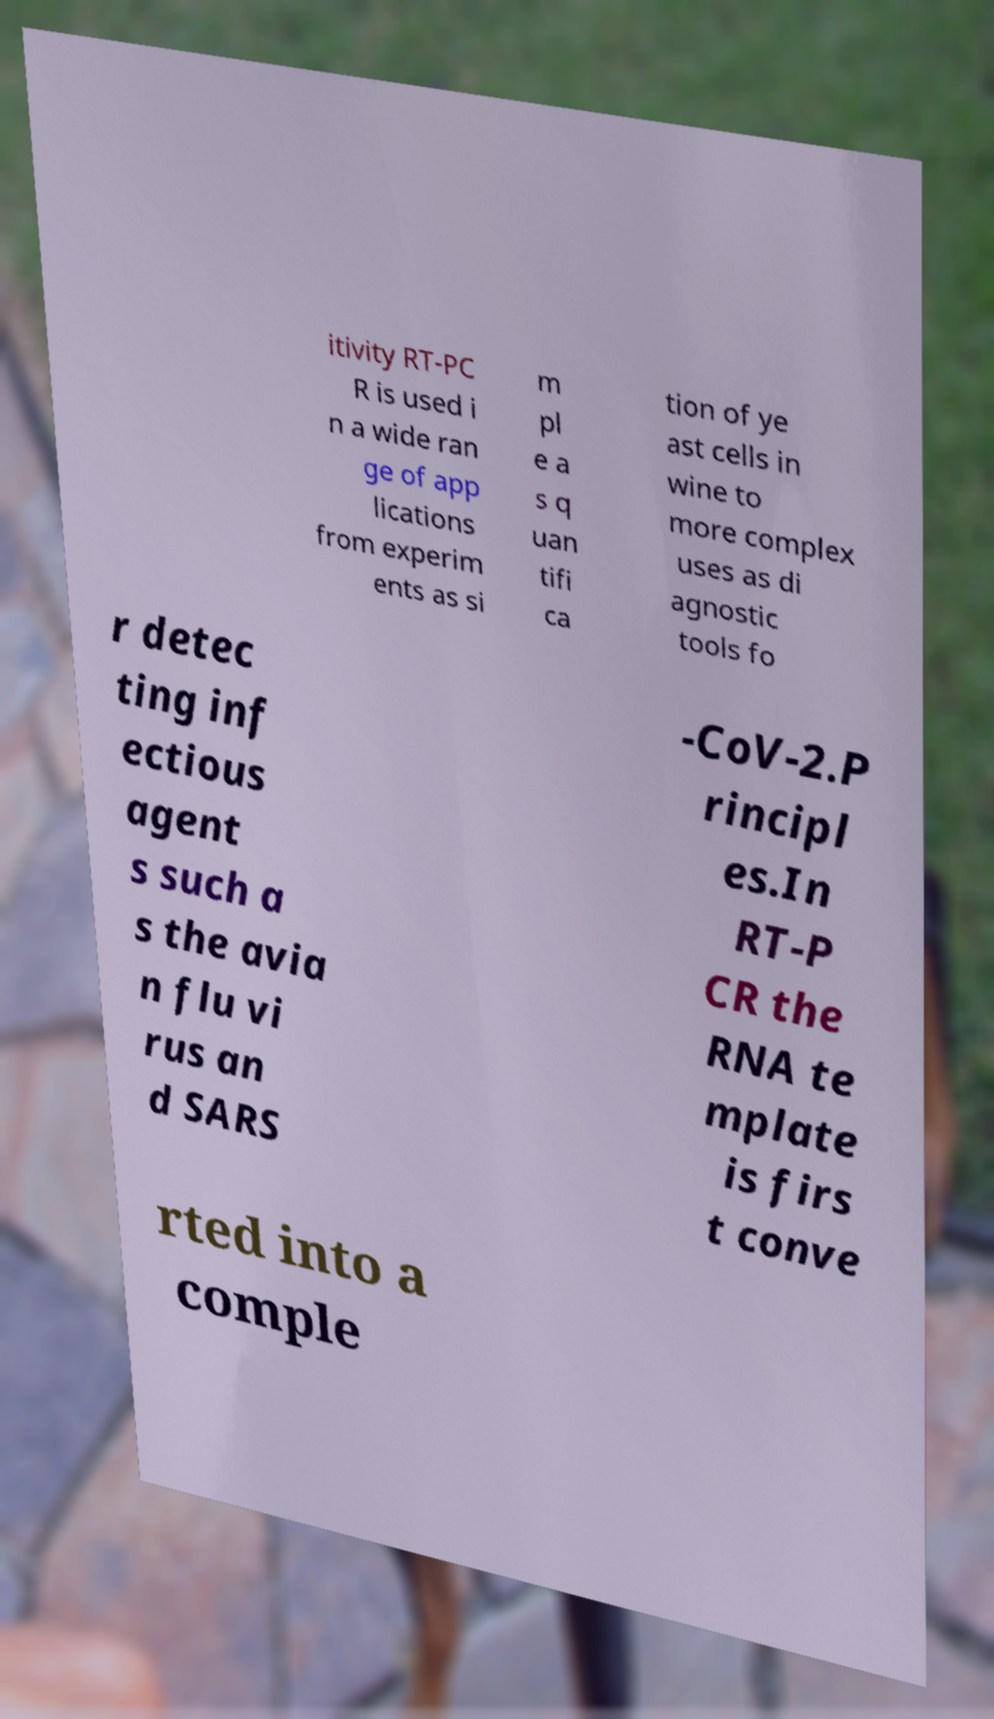Could you extract and type out the text from this image? itivity RT-PC R is used i n a wide ran ge of app lications from experim ents as si m pl e a s q uan tifi ca tion of ye ast cells in wine to more complex uses as di agnostic tools fo r detec ting inf ectious agent s such a s the avia n flu vi rus an d SARS -CoV-2.P rincipl es.In RT-P CR the RNA te mplate is firs t conve rted into a comple 